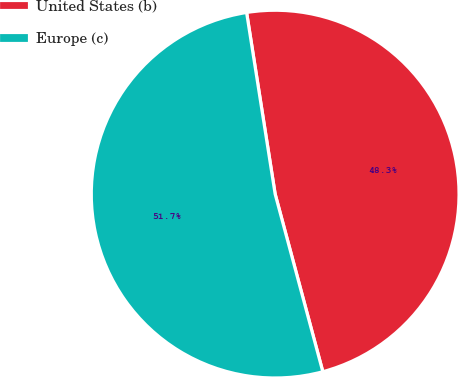Convert chart to OTSL. <chart><loc_0><loc_0><loc_500><loc_500><pie_chart><fcel>United States (b)<fcel>Europe (c)<nl><fcel>48.31%<fcel>51.69%<nl></chart> 